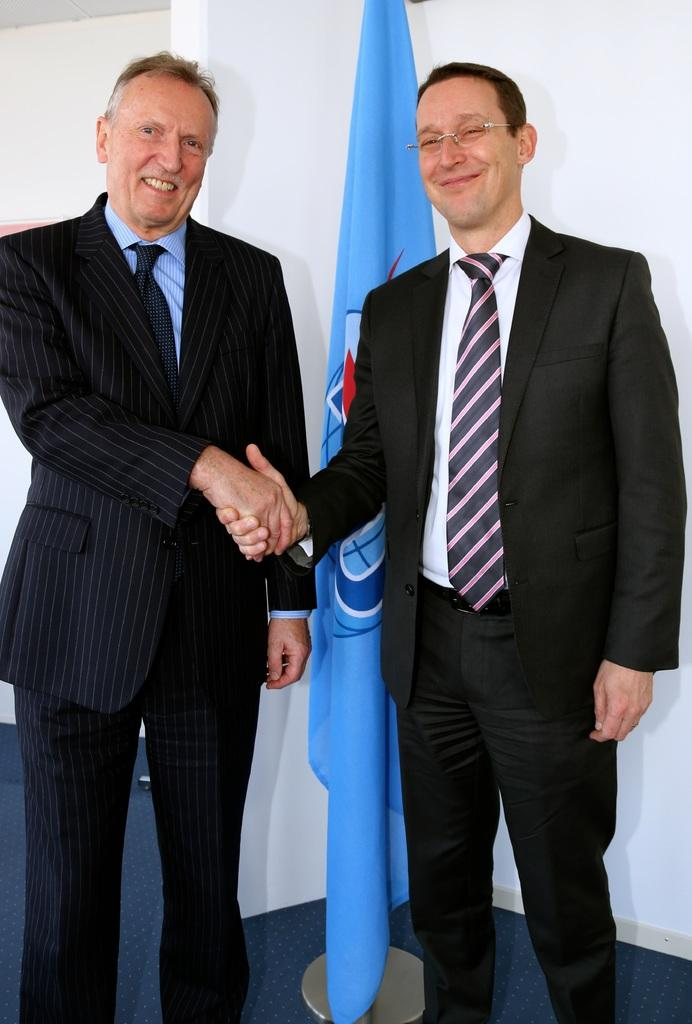How many people are in the image? There are two men in the image. What are the men doing in the image? The men are standing and smiling. What type of clothing are the men wearing? The men are wearing suits, shirts, ties, and trousers. What can be seen in the background of the image? There is a flag hanging on a pole and a white wall in the image. Can you tell me what type of pet is sitting next to the men in the image? There is no pet present in the image; it only features two men and the background elements. Is there a volcano visible in the image? No, there is no volcano present in the image. 